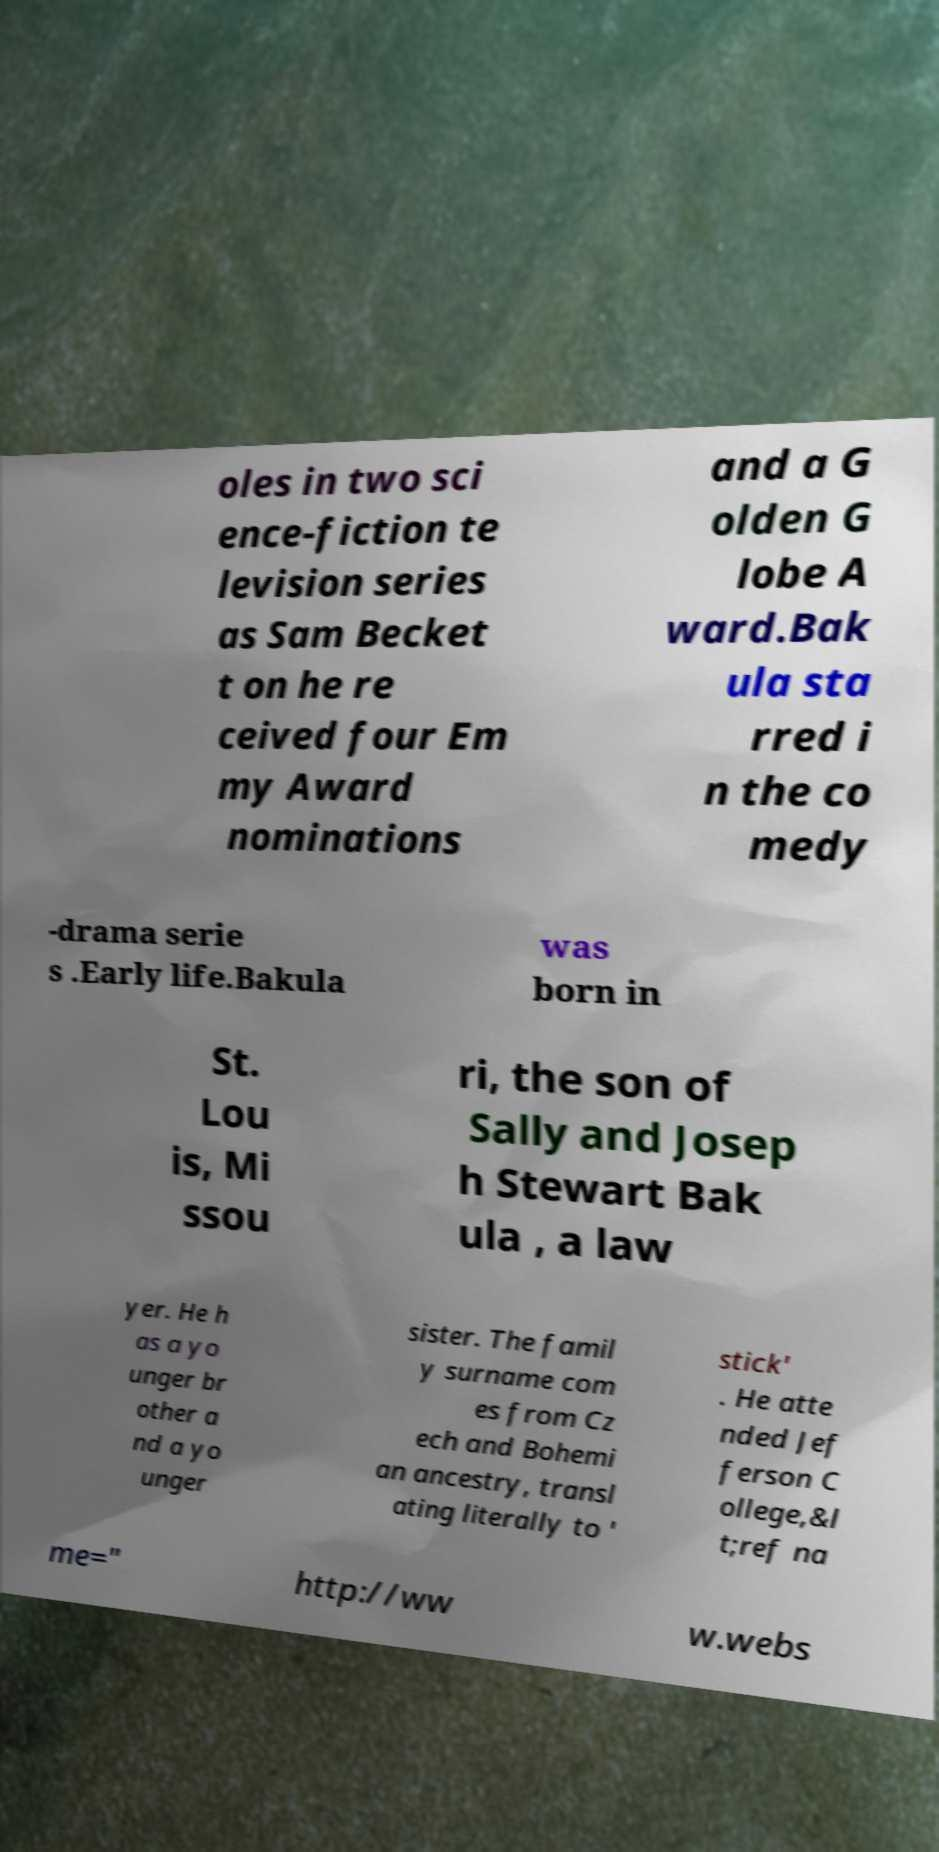For documentation purposes, I need the text within this image transcribed. Could you provide that? oles in two sci ence-fiction te levision series as Sam Becket t on he re ceived four Em my Award nominations and a G olden G lobe A ward.Bak ula sta rred i n the co medy -drama serie s .Early life.Bakula was born in St. Lou is, Mi ssou ri, the son of Sally and Josep h Stewart Bak ula , a law yer. He h as a yo unger br other a nd a yo unger sister. The famil y surname com es from Cz ech and Bohemi an ancestry, transl ating literally to ' stick' . He atte nded Jef ferson C ollege,&l t;ref na me=" http://ww w.webs 